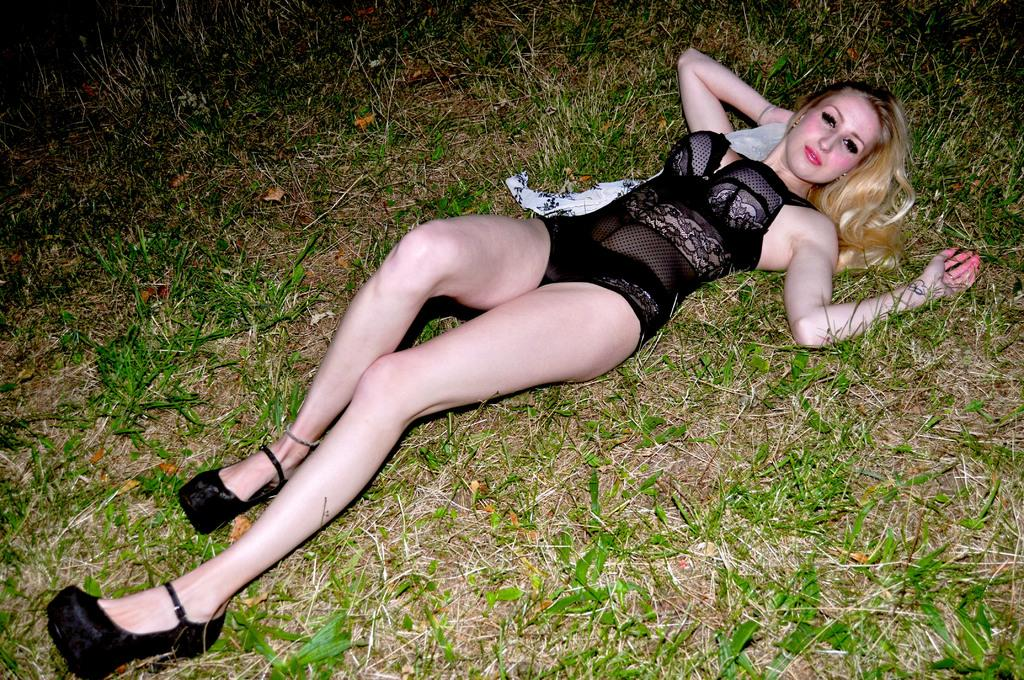What is the person in the image doing? The person is sleeping in the image. What is the person wearing while sleeping? The person is wearing a black dress. What type of vegetation can be seen in the image? There is green grass and dry grass visible in the image. What caption is written on the apple in the image? There is no apple present in the image, so there is no caption to be read. 